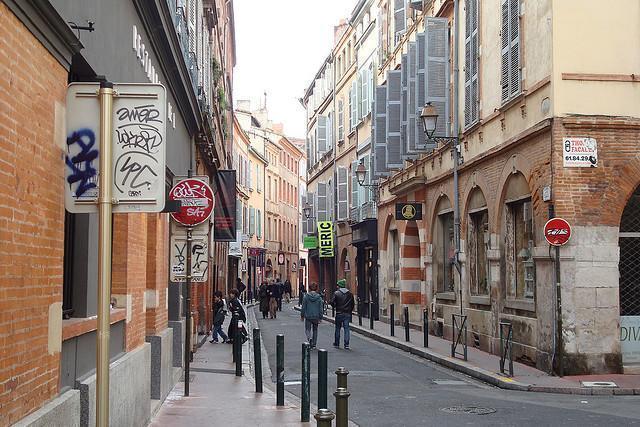What damage has been done in this street?
Pick the correct solution from the four options below to address the question.
Options: Cracked ground, illegal construction, graffiti, arson. Graffiti. 